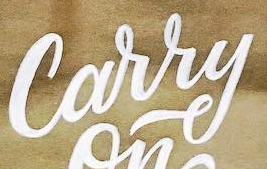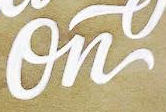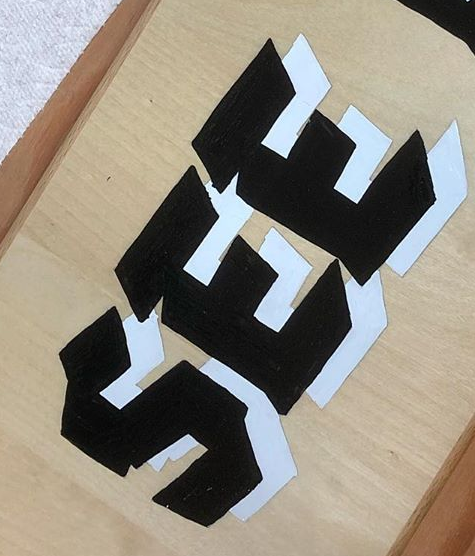What words can you see in these images in sequence, separated by a semicolon? Carry; On; SEE 